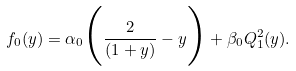<formula> <loc_0><loc_0><loc_500><loc_500>f _ { 0 } ( y ) = \alpha _ { 0 } \Big { ( } \frac { 2 } { ( 1 + y ) } - y \Big { ) } + \beta _ { 0 } Q ^ { 2 } _ { 1 } ( y ) .</formula> 